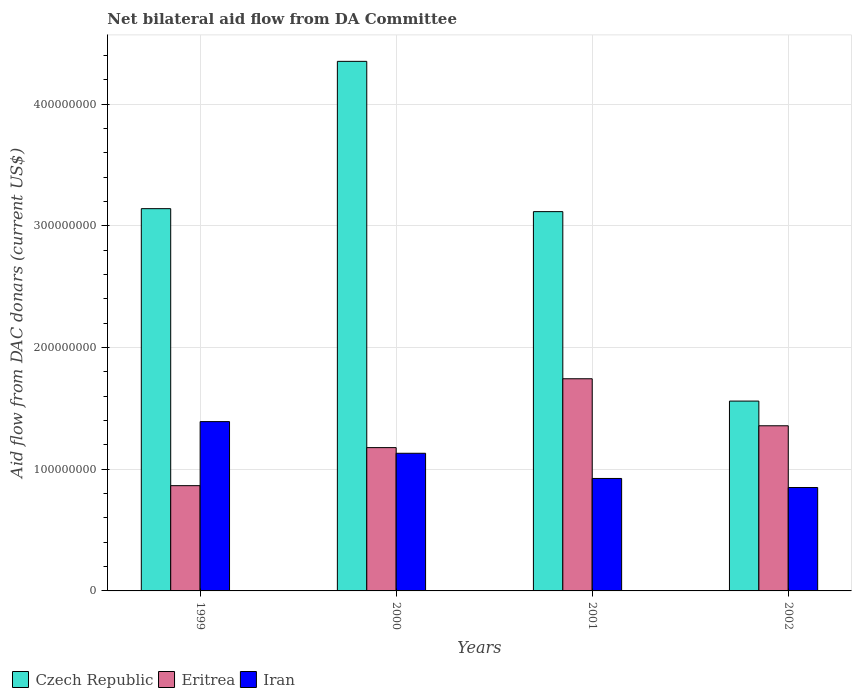Are the number of bars per tick equal to the number of legend labels?
Offer a terse response. Yes. How many bars are there on the 3rd tick from the right?
Provide a succinct answer. 3. What is the label of the 3rd group of bars from the left?
Your answer should be compact. 2001. In how many cases, is the number of bars for a given year not equal to the number of legend labels?
Offer a terse response. 0. What is the aid flow in in Czech Republic in 2000?
Give a very brief answer. 4.35e+08. Across all years, what is the maximum aid flow in in Czech Republic?
Ensure brevity in your answer.  4.35e+08. Across all years, what is the minimum aid flow in in Iran?
Your response must be concise. 8.50e+07. In which year was the aid flow in in Czech Republic maximum?
Make the answer very short. 2000. What is the total aid flow in in Eritrea in the graph?
Make the answer very short. 5.14e+08. What is the difference between the aid flow in in Eritrea in 1999 and that in 2000?
Ensure brevity in your answer.  -3.13e+07. What is the difference between the aid flow in in Eritrea in 2001 and the aid flow in in Iran in 2002?
Your response must be concise. 8.94e+07. What is the average aid flow in in Eritrea per year?
Provide a succinct answer. 1.29e+08. In the year 1999, what is the difference between the aid flow in in Eritrea and aid flow in in Czech Republic?
Provide a short and direct response. -2.28e+08. In how many years, is the aid flow in in Eritrea greater than 400000000 US$?
Provide a succinct answer. 0. What is the ratio of the aid flow in in Iran in 2000 to that in 2001?
Your answer should be compact. 1.22. Is the aid flow in in Czech Republic in 2001 less than that in 2002?
Give a very brief answer. No. What is the difference between the highest and the second highest aid flow in in Iran?
Your response must be concise. 2.60e+07. What is the difference between the highest and the lowest aid flow in in Czech Republic?
Your response must be concise. 2.79e+08. In how many years, is the aid flow in in Eritrea greater than the average aid flow in in Eritrea taken over all years?
Provide a short and direct response. 2. Is the sum of the aid flow in in Iran in 2000 and 2002 greater than the maximum aid flow in in Eritrea across all years?
Make the answer very short. Yes. What does the 1st bar from the left in 2001 represents?
Your response must be concise. Czech Republic. What does the 1st bar from the right in 2001 represents?
Offer a very short reply. Iran. How many bars are there?
Provide a succinct answer. 12. What is the difference between two consecutive major ticks on the Y-axis?
Ensure brevity in your answer.  1.00e+08. Are the values on the major ticks of Y-axis written in scientific E-notation?
Provide a short and direct response. No. What is the title of the graph?
Provide a succinct answer. Net bilateral aid flow from DA Committee. Does "Mongolia" appear as one of the legend labels in the graph?
Ensure brevity in your answer.  No. What is the label or title of the X-axis?
Provide a succinct answer. Years. What is the label or title of the Y-axis?
Your answer should be compact. Aid flow from DAC donars (current US$). What is the Aid flow from DAC donars (current US$) in Czech Republic in 1999?
Your answer should be very brief. 3.14e+08. What is the Aid flow from DAC donars (current US$) of Eritrea in 1999?
Make the answer very short. 8.65e+07. What is the Aid flow from DAC donars (current US$) of Iran in 1999?
Offer a terse response. 1.39e+08. What is the Aid flow from DAC donars (current US$) of Czech Republic in 2000?
Keep it short and to the point. 4.35e+08. What is the Aid flow from DAC donars (current US$) of Eritrea in 2000?
Give a very brief answer. 1.18e+08. What is the Aid flow from DAC donars (current US$) of Iran in 2000?
Give a very brief answer. 1.13e+08. What is the Aid flow from DAC donars (current US$) of Czech Republic in 2001?
Your response must be concise. 3.12e+08. What is the Aid flow from DAC donars (current US$) of Eritrea in 2001?
Ensure brevity in your answer.  1.74e+08. What is the Aid flow from DAC donars (current US$) in Iran in 2001?
Your answer should be compact. 9.24e+07. What is the Aid flow from DAC donars (current US$) in Czech Republic in 2002?
Give a very brief answer. 1.56e+08. What is the Aid flow from DAC donars (current US$) of Eritrea in 2002?
Ensure brevity in your answer.  1.36e+08. What is the Aid flow from DAC donars (current US$) in Iran in 2002?
Keep it short and to the point. 8.50e+07. Across all years, what is the maximum Aid flow from DAC donars (current US$) in Czech Republic?
Your answer should be compact. 4.35e+08. Across all years, what is the maximum Aid flow from DAC donars (current US$) of Eritrea?
Your answer should be very brief. 1.74e+08. Across all years, what is the maximum Aid flow from DAC donars (current US$) in Iran?
Your response must be concise. 1.39e+08. Across all years, what is the minimum Aid flow from DAC donars (current US$) in Czech Republic?
Ensure brevity in your answer.  1.56e+08. Across all years, what is the minimum Aid flow from DAC donars (current US$) in Eritrea?
Offer a terse response. 8.65e+07. Across all years, what is the minimum Aid flow from DAC donars (current US$) in Iran?
Ensure brevity in your answer.  8.50e+07. What is the total Aid flow from DAC donars (current US$) in Czech Republic in the graph?
Offer a very short reply. 1.22e+09. What is the total Aid flow from DAC donars (current US$) in Eritrea in the graph?
Offer a very short reply. 5.14e+08. What is the total Aid flow from DAC donars (current US$) in Iran in the graph?
Make the answer very short. 4.30e+08. What is the difference between the Aid flow from DAC donars (current US$) of Czech Republic in 1999 and that in 2000?
Provide a succinct answer. -1.21e+08. What is the difference between the Aid flow from DAC donars (current US$) of Eritrea in 1999 and that in 2000?
Offer a very short reply. -3.13e+07. What is the difference between the Aid flow from DAC donars (current US$) of Iran in 1999 and that in 2000?
Your response must be concise. 2.60e+07. What is the difference between the Aid flow from DAC donars (current US$) in Czech Republic in 1999 and that in 2001?
Provide a succinct answer. 2.44e+06. What is the difference between the Aid flow from DAC donars (current US$) in Eritrea in 1999 and that in 2001?
Offer a very short reply. -8.78e+07. What is the difference between the Aid flow from DAC donars (current US$) of Iran in 1999 and that in 2001?
Your response must be concise. 4.67e+07. What is the difference between the Aid flow from DAC donars (current US$) in Czech Republic in 1999 and that in 2002?
Ensure brevity in your answer.  1.58e+08. What is the difference between the Aid flow from DAC donars (current US$) of Eritrea in 1999 and that in 2002?
Keep it short and to the point. -4.92e+07. What is the difference between the Aid flow from DAC donars (current US$) of Iran in 1999 and that in 2002?
Provide a succinct answer. 5.42e+07. What is the difference between the Aid flow from DAC donars (current US$) of Czech Republic in 2000 and that in 2001?
Give a very brief answer. 1.24e+08. What is the difference between the Aid flow from DAC donars (current US$) in Eritrea in 2000 and that in 2001?
Keep it short and to the point. -5.66e+07. What is the difference between the Aid flow from DAC donars (current US$) of Iran in 2000 and that in 2001?
Ensure brevity in your answer.  2.07e+07. What is the difference between the Aid flow from DAC donars (current US$) of Czech Republic in 2000 and that in 2002?
Keep it short and to the point. 2.79e+08. What is the difference between the Aid flow from DAC donars (current US$) in Eritrea in 2000 and that in 2002?
Your answer should be compact. -1.80e+07. What is the difference between the Aid flow from DAC donars (current US$) in Iran in 2000 and that in 2002?
Provide a short and direct response. 2.81e+07. What is the difference between the Aid flow from DAC donars (current US$) in Czech Republic in 2001 and that in 2002?
Your answer should be compact. 1.56e+08. What is the difference between the Aid flow from DAC donars (current US$) of Eritrea in 2001 and that in 2002?
Give a very brief answer. 3.86e+07. What is the difference between the Aid flow from DAC donars (current US$) in Iran in 2001 and that in 2002?
Your response must be concise. 7.45e+06. What is the difference between the Aid flow from DAC donars (current US$) of Czech Republic in 1999 and the Aid flow from DAC donars (current US$) of Eritrea in 2000?
Your answer should be very brief. 1.96e+08. What is the difference between the Aid flow from DAC donars (current US$) of Czech Republic in 1999 and the Aid flow from DAC donars (current US$) of Iran in 2000?
Provide a succinct answer. 2.01e+08. What is the difference between the Aid flow from DAC donars (current US$) of Eritrea in 1999 and the Aid flow from DAC donars (current US$) of Iran in 2000?
Ensure brevity in your answer.  -2.66e+07. What is the difference between the Aid flow from DAC donars (current US$) in Czech Republic in 1999 and the Aid flow from DAC donars (current US$) in Eritrea in 2001?
Ensure brevity in your answer.  1.40e+08. What is the difference between the Aid flow from DAC donars (current US$) of Czech Republic in 1999 and the Aid flow from DAC donars (current US$) of Iran in 2001?
Ensure brevity in your answer.  2.22e+08. What is the difference between the Aid flow from DAC donars (current US$) in Eritrea in 1999 and the Aid flow from DAC donars (current US$) in Iran in 2001?
Offer a terse response. -5.92e+06. What is the difference between the Aid flow from DAC donars (current US$) in Czech Republic in 1999 and the Aid flow from DAC donars (current US$) in Eritrea in 2002?
Provide a short and direct response. 1.78e+08. What is the difference between the Aid flow from DAC donars (current US$) of Czech Republic in 1999 and the Aid flow from DAC donars (current US$) of Iran in 2002?
Provide a succinct answer. 2.29e+08. What is the difference between the Aid flow from DAC donars (current US$) of Eritrea in 1999 and the Aid flow from DAC donars (current US$) of Iran in 2002?
Ensure brevity in your answer.  1.53e+06. What is the difference between the Aid flow from DAC donars (current US$) of Czech Republic in 2000 and the Aid flow from DAC donars (current US$) of Eritrea in 2001?
Ensure brevity in your answer.  2.61e+08. What is the difference between the Aid flow from DAC donars (current US$) in Czech Republic in 2000 and the Aid flow from DAC donars (current US$) in Iran in 2001?
Make the answer very short. 3.43e+08. What is the difference between the Aid flow from DAC donars (current US$) of Eritrea in 2000 and the Aid flow from DAC donars (current US$) of Iran in 2001?
Give a very brief answer. 2.53e+07. What is the difference between the Aid flow from DAC donars (current US$) in Czech Republic in 2000 and the Aid flow from DAC donars (current US$) in Eritrea in 2002?
Ensure brevity in your answer.  3.00e+08. What is the difference between the Aid flow from DAC donars (current US$) in Czech Republic in 2000 and the Aid flow from DAC donars (current US$) in Iran in 2002?
Your answer should be compact. 3.50e+08. What is the difference between the Aid flow from DAC donars (current US$) in Eritrea in 2000 and the Aid flow from DAC donars (current US$) in Iran in 2002?
Your response must be concise. 3.28e+07. What is the difference between the Aid flow from DAC donars (current US$) of Czech Republic in 2001 and the Aid flow from DAC donars (current US$) of Eritrea in 2002?
Provide a succinct answer. 1.76e+08. What is the difference between the Aid flow from DAC donars (current US$) in Czech Republic in 2001 and the Aid flow from DAC donars (current US$) in Iran in 2002?
Make the answer very short. 2.27e+08. What is the difference between the Aid flow from DAC donars (current US$) of Eritrea in 2001 and the Aid flow from DAC donars (current US$) of Iran in 2002?
Offer a very short reply. 8.94e+07. What is the average Aid flow from DAC donars (current US$) in Czech Republic per year?
Your answer should be very brief. 3.04e+08. What is the average Aid flow from DAC donars (current US$) of Eritrea per year?
Offer a very short reply. 1.29e+08. What is the average Aid flow from DAC donars (current US$) of Iran per year?
Provide a succinct answer. 1.07e+08. In the year 1999, what is the difference between the Aid flow from DAC donars (current US$) of Czech Republic and Aid flow from DAC donars (current US$) of Eritrea?
Your answer should be very brief. 2.28e+08. In the year 1999, what is the difference between the Aid flow from DAC donars (current US$) in Czech Republic and Aid flow from DAC donars (current US$) in Iran?
Your answer should be very brief. 1.75e+08. In the year 1999, what is the difference between the Aid flow from DAC donars (current US$) in Eritrea and Aid flow from DAC donars (current US$) in Iran?
Provide a short and direct response. -5.26e+07. In the year 2000, what is the difference between the Aid flow from DAC donars (current US$) of Czech Republic and Aid flow from DAC donars (current US$) of Eritrea?
Offer a very short reply. 3.17e+08. In the year 2000, what is the difference between the Aid flow from DAC donars (current US$) of Czech Republic and Aid flow from DAC donars (current US$) of Iran?
Your answer should be very brief. 3.22e+08. In the year 2000, what is the difference between the Aid flow from DAC donars (current US$) in Eritrea and Aid flow from DAC donars (current US$) in Iran?
Provide a succinct answer. 4.65e+06. In the year 2001, what is the difference between the Aid flow from DAC donars (current US$) of Czech Republic and Aid flow from DAC donars (current US$) of Eritrea?
Your answer should be compact. 1.37e+08. In the year 2001, what is the difference between the Aid flow from DAC donars (current US$) in Czech Republic and Aid flow from DAC donars (current US$) in Iran?
Keep it short and to the point. 2.19e+08. In the year 2001, what is the difference between the Aid flow from DAC donars (current US$) in Eritrea and Aid flow from DAC donars (current US$) in Iran?
Ensure brevity in your answer.  8.19e+07. In the year 2002, what is the difference between the Aid flow from DAC donars (current US$) in Czech Republic and Aid flow from DAC donars (current US$) in Eritrea?
Provide a short and direct response. 2.03e+07. In the year 2002, what is the difference between the Aid flow from DAC donars (current US$) in Czech Republic and Aid flow from DAC donars (current US$) in Iran?
Your answer should be compact. 7.10e+07. In the year 2002, what is the difference between the Aid flow from DAC donars (current US$) of Eritrea and Aid flow from DAC donars (current US$) of Iran?
Make the answer very short. 5.07e+07. What is the ratio of the Aid flow from DAC donars (current US$) of Czech Republic in 1999 to that in 2000?
Keep it short and to the point. 0.72. What is the ratio of the Aid flow from DAC donars (current US$) in Eritrea in 1999 to that in 2000?
Your response must be concise. 0.73. What is the ratio of the Aid flow from DAC donars (current US$) in Iran in 1999 to that in 2000?
Offer a very short reply. 1.23. What is the ratio of the Aid flow from DAC donars (current US$) in Eritrea in 1999 to that in 2001?
Keep it short and to the point. 0.5. What is the ratio of the Aid flow from DAC donars (current US$) of Iran in 1999 to that in 2001?
Ensure brevity in your answer.  1.51. What is the ratio of the Aid flow from DAC donars (current US$) of Czech Republic in 1999 to that in 2002?
Ensure brevity in your answer.  2.01. What is the ratio of the Aid flow from DAC donars (current US$) in Eritrea in 1999 to that in 2002?
Keep it short and to the point. 0.64. What is the ratio of the Aid flow from DAC donars (current US$) in Iran in 1999 to that in 2002?
Your answer should be compact. 1.64. What is the ratio of the Aid flow from DAC donars (current US$) of Czech Republic in 2000 to that in 2001?
Offer a very short reply. 1.4. What is the ratio of the Aid flow from DAC donars (current US$) in Eritrea in 2000 to that in 2001?
Ensure brevity in your answer.  0.68. What is the ratio of the Aid flow from DAC donars (current US$) of Iran in 2000 to that in 2001?
Provide a short and direct response. 1.22. What is the ratio of the Aid flow from DAC donars (current US$) of Czech Republic in 2000 to that in 2002?
Provide a short and direct response. 2.79. What is the ratio of the Aid flow from DAC donars (current US$) of Eritrea in 2000 to that in 2002?
Make the answer very short. 0.87. What is the ratio of the Aid flow from DAC donars (current US$) in Iran in 2000 to that in 2002?
Your answer should be very brief. 1.33. What is the ratio of the Aid flow from DAC donars (current US$) in Czech Republic in 2001 to that in 2002?
Provide a short and direct response. 2. What is the ratio of the Aid flow from DAC donars (current US$) in Eritrea in 2001 to that in 2002?
Provide a short and direct response. 1.28. What is the ratio of the Aid flow from DAC donars (current US$) of Iran in 2001 to that in 2002?
Offer a terse response. 1.09. What is the difference between the highest and the second highest Aid flow from DAC donars (current US$) of Czech Republic?
Make the answer very short. 1.21e+08. What is the difference between the highest and the second highest Aid flow from DAC donars (current US$) in Eritrea?
Keep it short and to the point. 3.86e+07. What is the difference between the highest and the second highest Aid flow from DAC donars (current US$) in Iran?
Offer a terse response. 2.60e+07. What is the difference between the highest and the lowest Aid flow from DAC donars (current US$) of Czech Republic?
Keep it short and to the point. 2.79e+08. What is the difference between the highest and the lowest Aid flow from DAC donars (current US$) of Eritrea?
Ensure brevity in your answer.  8.78e+07. What is the difference between the highest and the lowest Aid flow from DAC donars (current US$) in Iran?
Offer a very short reply. 5.42e+07. 